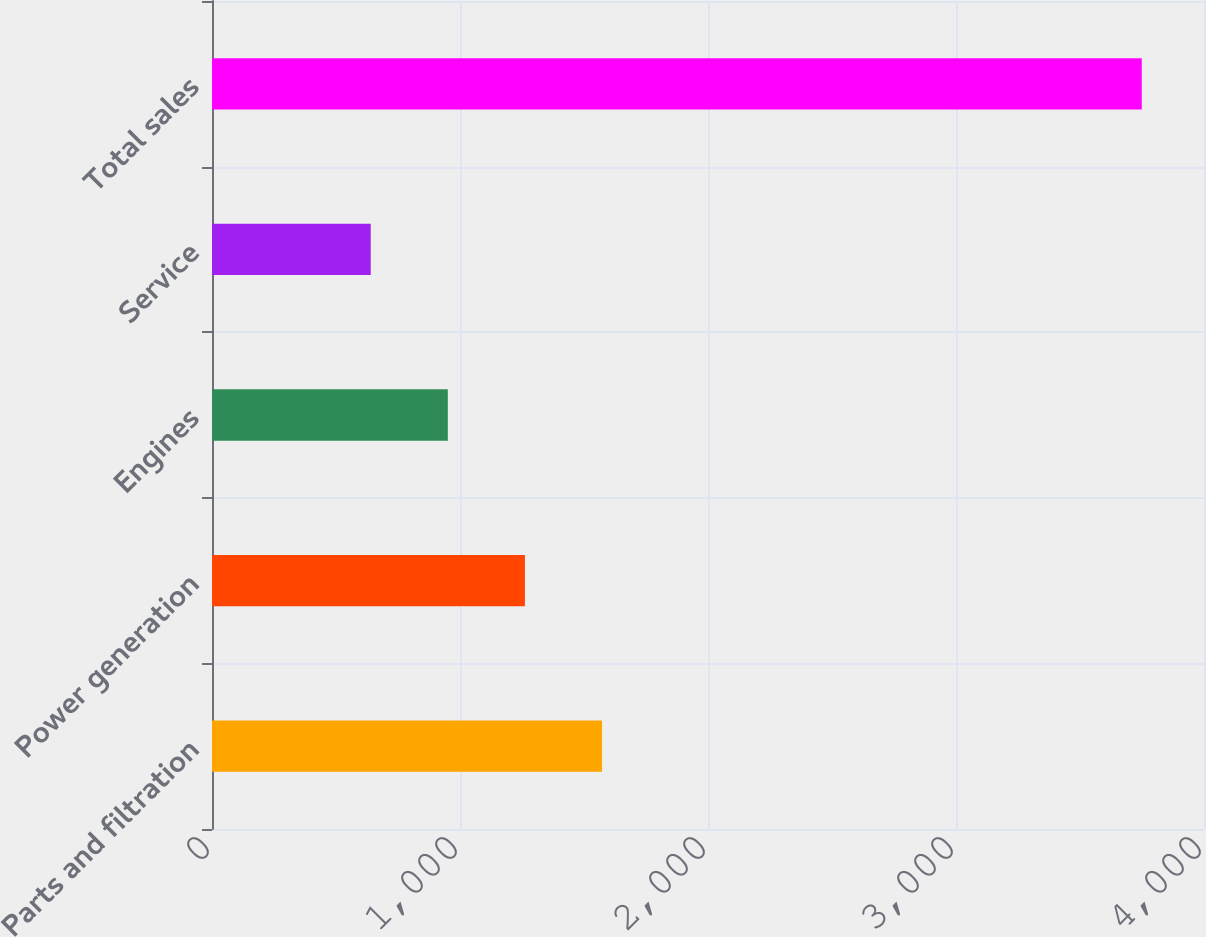Convert chart. <chart><loc_0><loc_0><loc_500><loc_500><bar_chart><fcel>Parts and filtration<fcel>Power generation<fcel>Engines<fcel>Service<fcel>Total sales<nl><fcel>1572.7<fcel>1261.8<fcel>950.9<fcel>640<fcel>3749<nl></chart> 